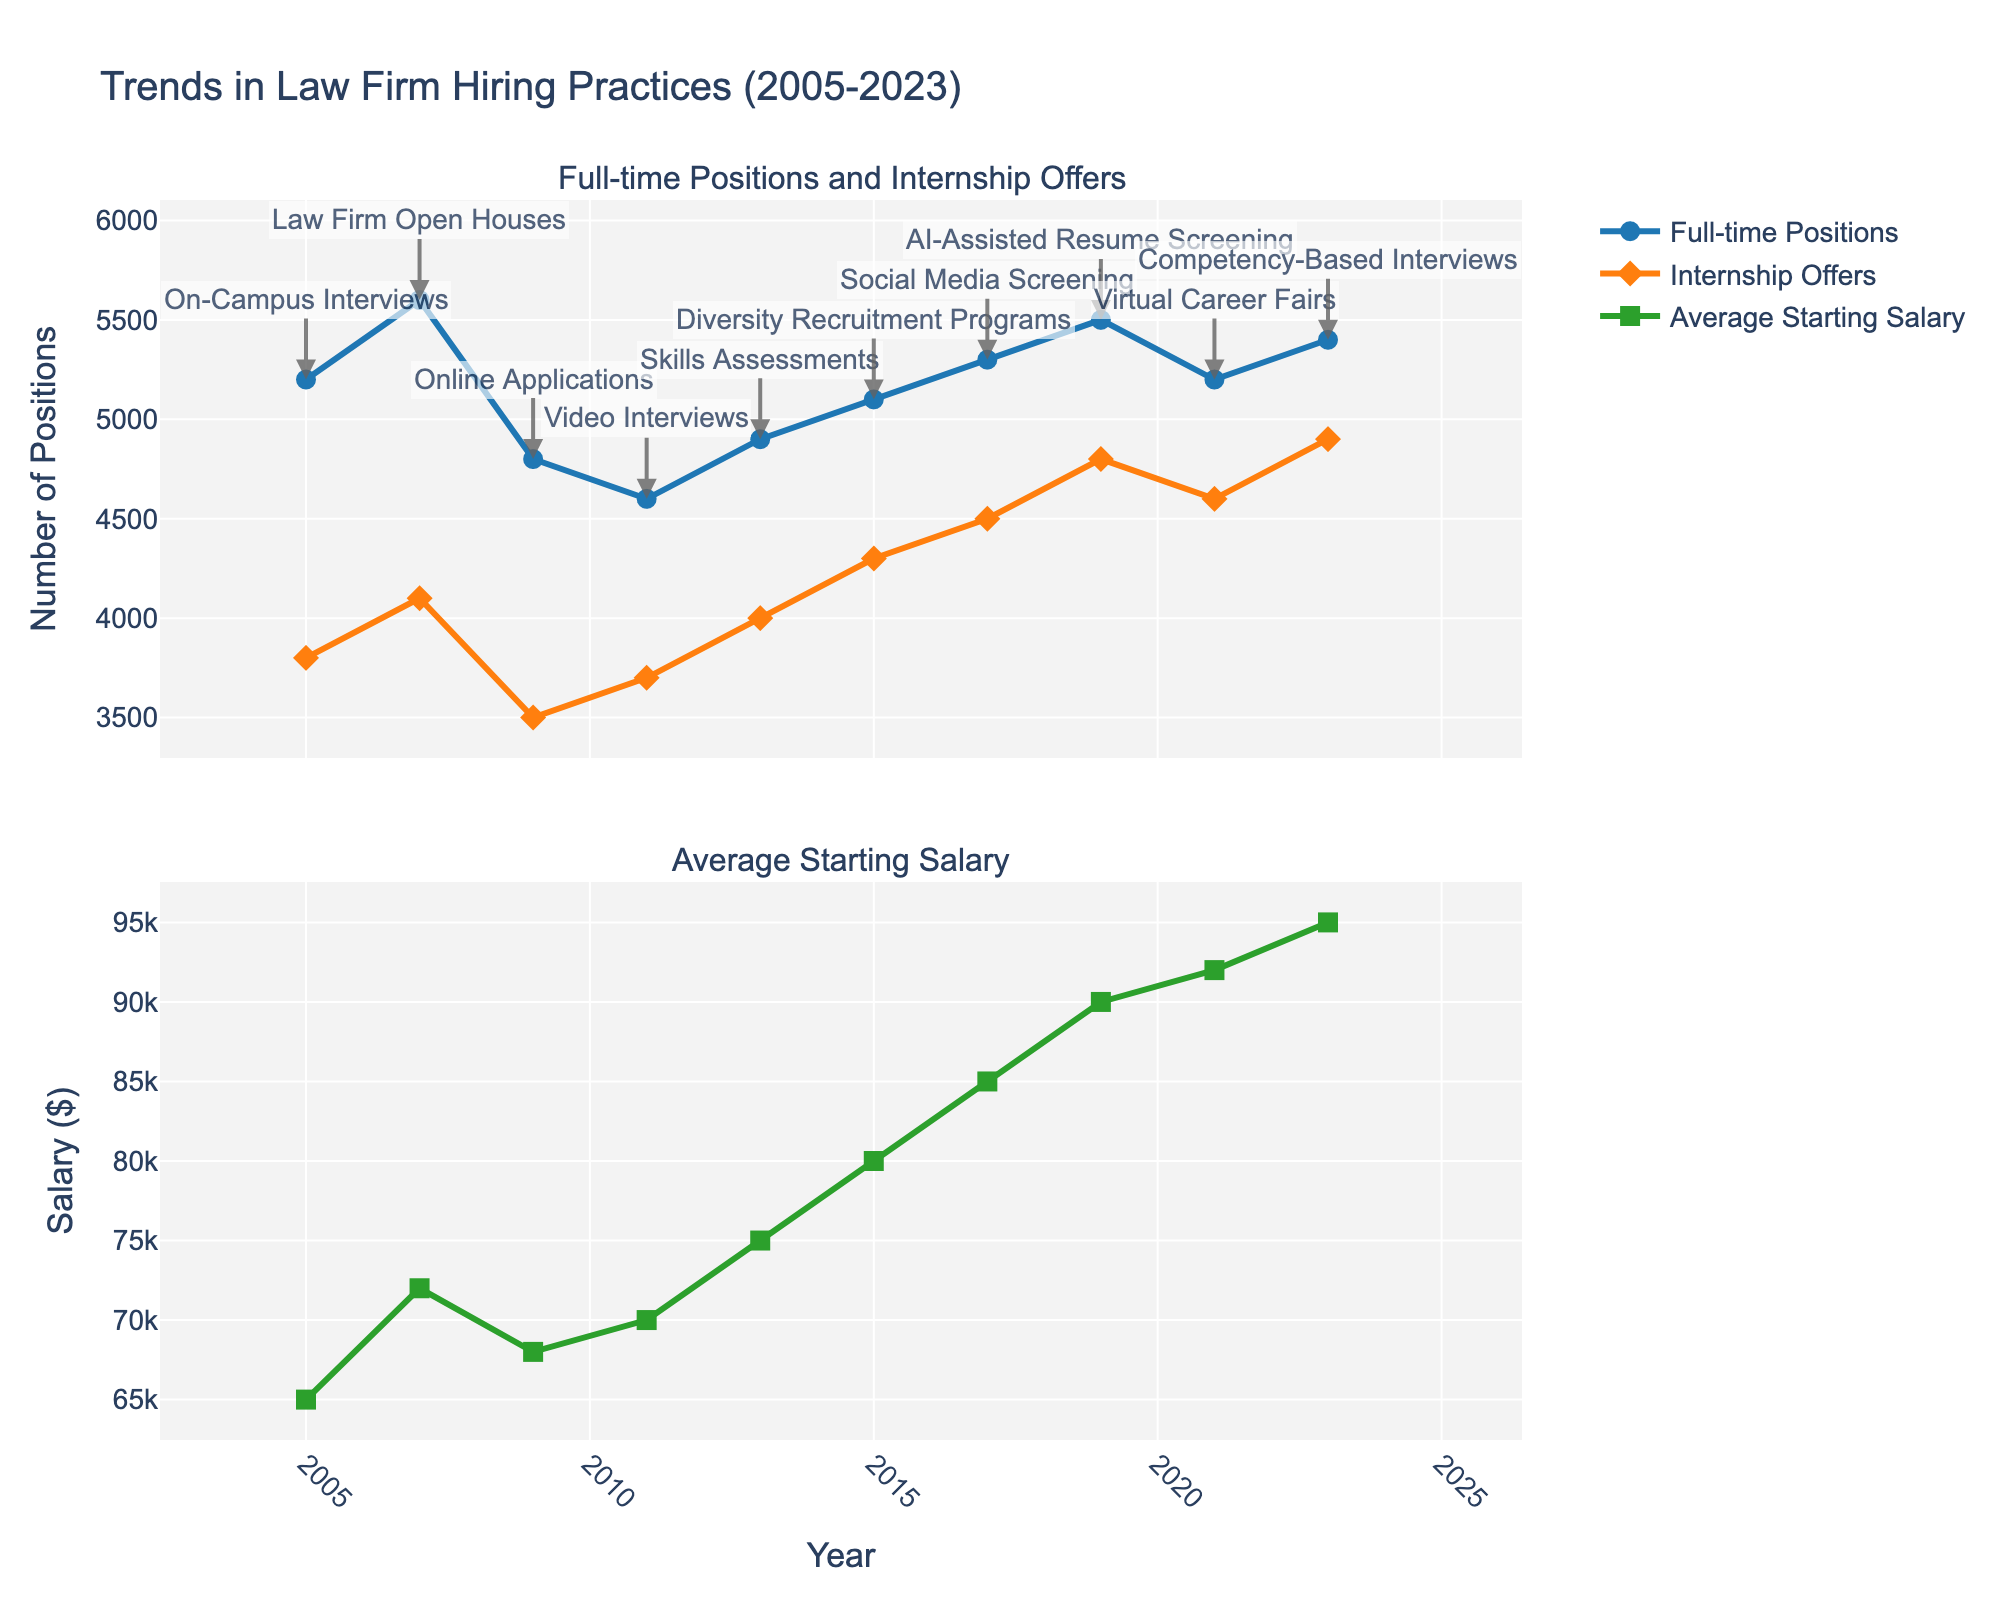What was the trend in the number of Full-time Positions from 2005 to 2023? The number of Full-time Positions increased from 5200 in 2005 to a peak of 5600 in 2019, followed by a decrease to 5200 in 2021, and a slight rise to 5400 in 2023.
Answer: Overall increase When did the average starting salary see the highest jump between two consecutive data points? By looking at the changes in average starting salary for each time period, we see the highest jump of $5000 happened between 2015 ($80000) and 2017 ($85000).
Answer: 2015-2017 Which year had the highest number of Internship Offers? The year 2023 had the highest number of Internship Offers, totaling 4900.
Answer: 2023 Compare the number of Full-time Positions and Internship Offers in 2019. Which was higher and by how much? In 2019, Full-time Positions were 5500 and Internship Offers were 4800. The difference is 5500 - 4800 = 700.
Answer: Full-time Positions by 700 What was the average starting salary in 2011, and how does it compare to 2023? The average starting salary in 2011 was $70000, while in 2023 it was $95000. The increase is $95000 - $70000 = $25000.
Answer: Increased by $25000 In which year was the top hiring practice "AI-Assisted Resume Screening"? The figure notes "AI-Assisted Resume Screening" as the top hiring practice in 2019.
Answer: 2019 By how much did the number of Internship Offers increase from 2005 to 2023? In 2005, there were 3800 Internship Offers, and in 2023, there were 4900. The increase is 4900 - 3800 = 1100.
Answer: Increased by 1100 Which year saw the lowest number of Full-time Positions and what was the corresponding hiring practice? The lowest number of Full-time Positions was in 2011, with 4600 Full-time Positions. The top hiring practice for this year was Video Interviews.
Answer: 2011, Video Interviews How did the number of Internship Offers change from 2017 to 2019, and what might this suggest? The number of Internship Offers increased from 4500 in 2017 to 4800 in 2019. This suggests a growing trend in offering internships during these years.
Answer: Increased by 300 